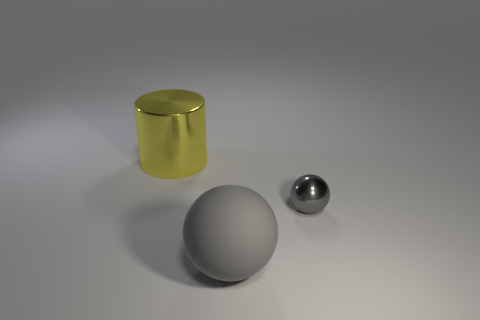Can you describe the lighting and mood of the scene? The lighting in the image creates a soft and diffuse atmosphere, with gentle shadows that suggest an overhead light source. The lack of harsh shadows indicates that the light may be scattered, possibly through a softbox or similar diffusion method. This controlled lighting setup contributes to a calm and serene mood, emphasizing the sleek and simple design of the objects. The neutral background helps focus attention on the objects without any distractions. 